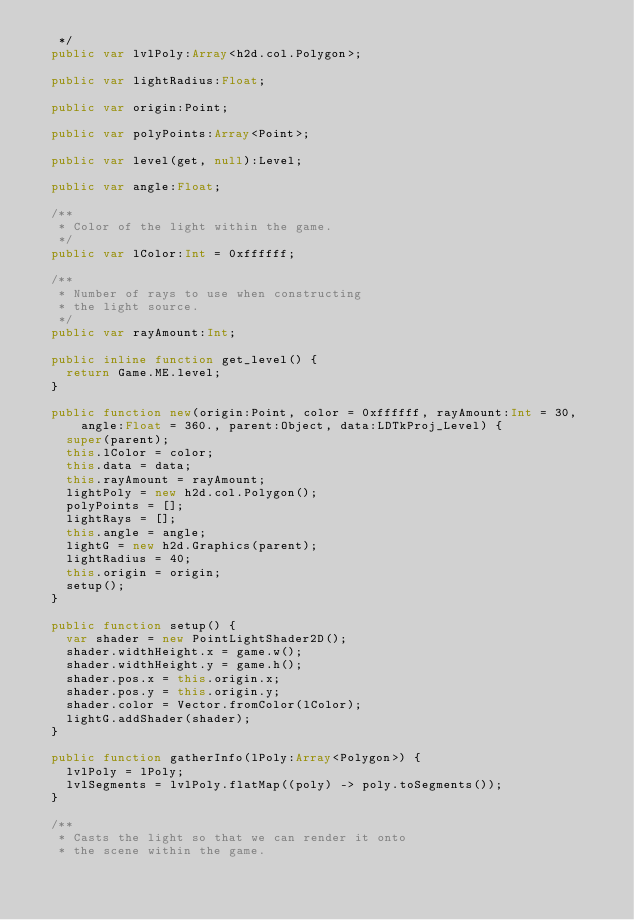Convert code to text. <code><loc_0><loc_0><loc_500><loc_500><_Haxe_>   */
  public var lvlPoly:Array<h2d.col.Polygon>;

  public var lightRadius:Float;

  public var origin:Point;

  public var polyPoints:Array<Point>;

  public var level(get, null):Level;

  public var angle:Float;

  /**
   * Color of the light within the game.
   */
  public var lColor:Int = 0xffffff;

  /**
   * Number of rays to use when constructing
   * the light source.
   */
  public var rayAmount:Int;

  public inline function get_level() {
    return Game.ME.level;
  }

  public function new(origin:Point, color = 0xffffff, rayAmount:Int = 30,
      angle:Float = 360., parent:Object, data:LDTkProj_Level) {
    super(parent);
    this.lColor = color;
    this.data = data;
    this.rayAmount = rayAmount;
    lightPoly = new h2d.col.Polygon();
    polyPoints = [];
    lightRays = [];
    this.angle = angle;
    lightG = new h2d.Graphics(parent);
    lightRadius = 40;
    this.origin = origin;
    setup();
  }

  public function setup() {
    var shader = new PointLightShader2D();
    shader.widthHeight.x = game.w();
    shader.widthHeight.y = game.h();
    shader.pos.x = this.origin.x;
    shader.pos.y = this.origin.y;
    shader.color = Vector.fromColor(lColor);
    lightG.addShader(shader);
  }

  public function gatherInfo(lPoly:Array<Polygon>) {
    lvlPoly = lPoly;
    lvlSegments = lvlPoly.flatMap((poly) -> poly.toSegments());
  }

  /**
   * Casts the light so that we can render it onto
   * the scene within the game.</code> 